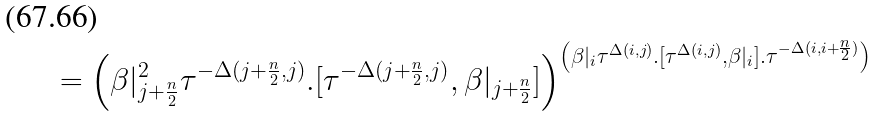Convert formula to latex. <formula><loc_0><loc_0><loc_500><loc_500>= \left ( \beta | _ { j + \frac { n } { 2 } } ^ { 2 } \tau ^ { - \Delta ( j + \frac { n } { 2 } , j ) } . [ \tau ^ { - \Delta ( j + \frac { n } { 2 } , j ) } , \beta | _ { j + \frac { n } { 2 } } ] \right ) ^ { \left ( \beta | _ { i } \tau ^ { \Delta ( i , j ) } . [ \tau ^ { \Delta ( i , j ) } , \beta | _ { i } ] . \tau ^ { - \Delta ( i , i + \frac { n } { 2 } ) } \right ) }</formula> 